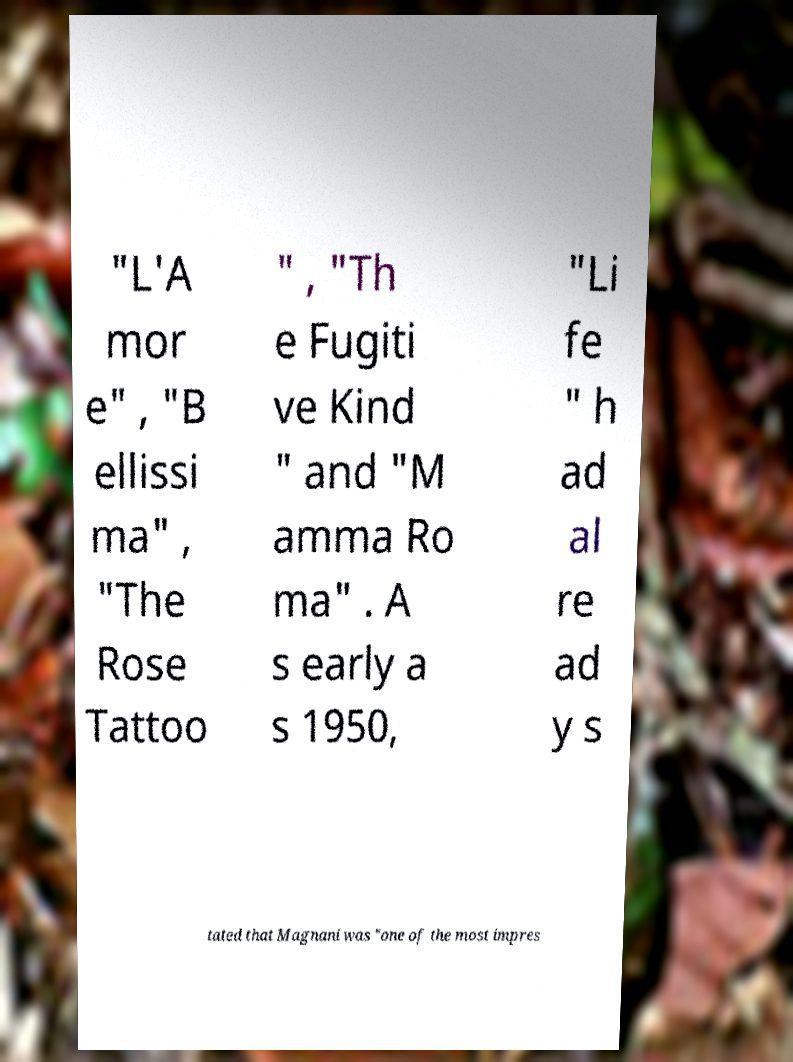Could you assist in decoding the text presented in this image and type it out clearly? "L'A mor e" , "B ellissi ma" , "The Rose Tattoo " , "Th e Fugiti ve Kind " and "M amma Ro ma" . A s early a s 1950, "Li fe " h ad al re ad y s tated that Magnani was "one of the most impres 